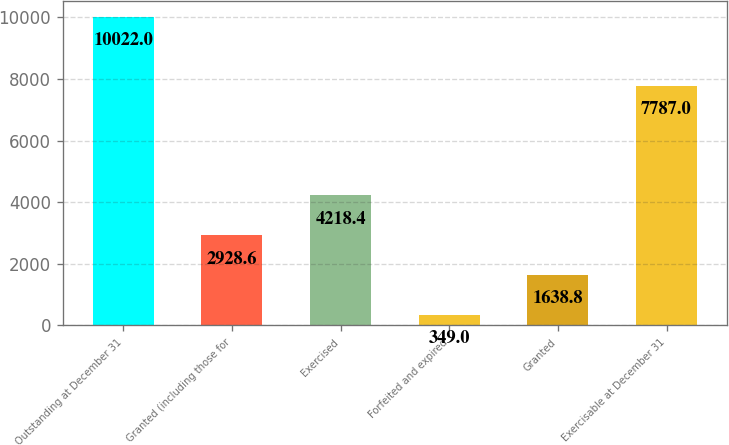<chart> <loc_0><loc_0><loc_500><loc_500><bar_chart><fcel>Outstanding at December 31<fcel>Granted (including those for<fcel>Exercised<fcel>Forfeited and expired<fcel>Granted<fcel>Exercisable at December 31<nl><fcel>10022<fcel>2928.6<fcel>4218.4<fcel>349<fcel>1638.8<fcel>7787<nl></chart> 